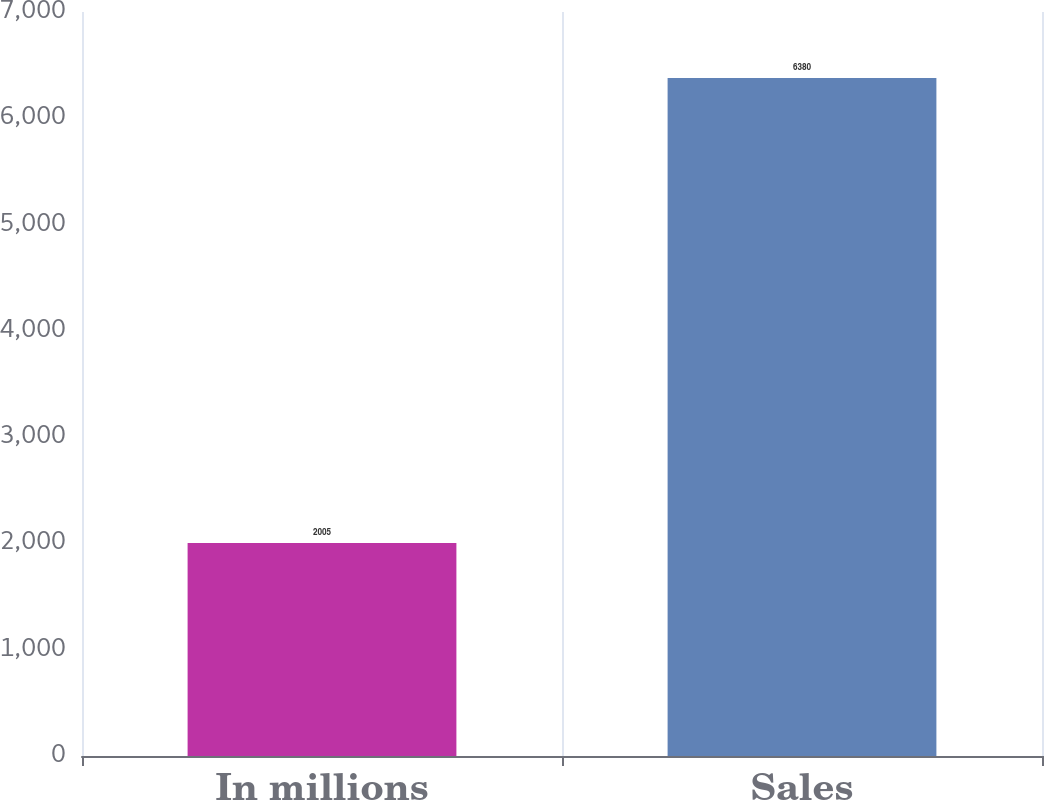Convert chart. <chart><loc_0><loc_0><loc_500><loc_500><bar_chart><fcel>In millions<fcel>Sales<nl><fcel>2005<fcel>6380<nl></chart> 